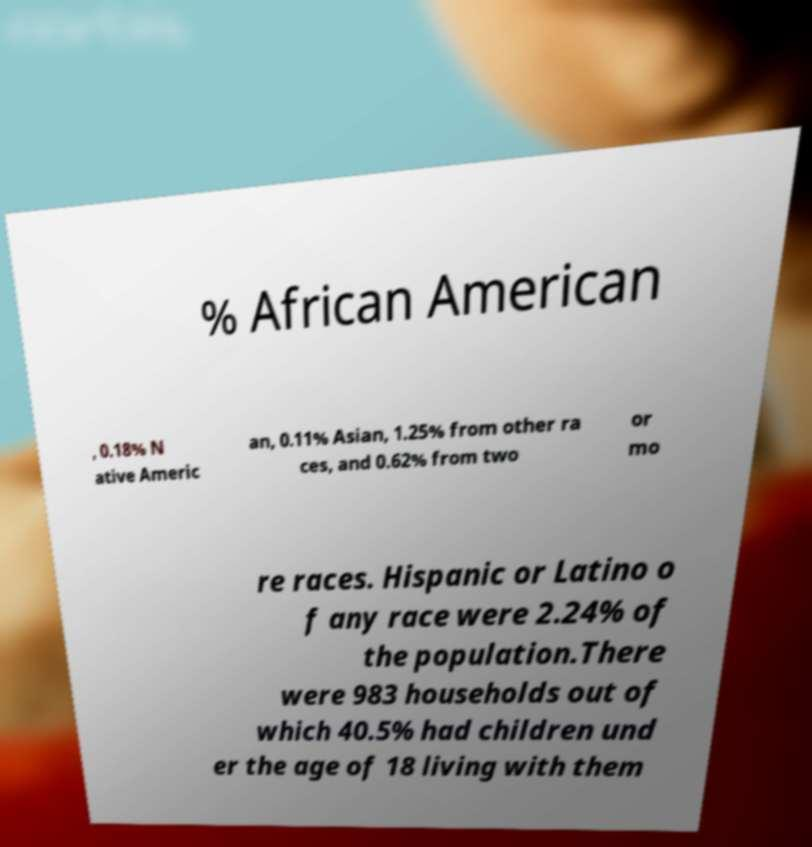Please identify and transcribe the text found in this image. % African American , 0.18% N ative Americ an, 0.11% Asian, 1.25% from other ra ces, and 0.62% from two or mo re races. Hispanic or Latino o f any race were 2.24% of the population.There were 983 households out of which 40.5% had children und er the age of 18 living with them 